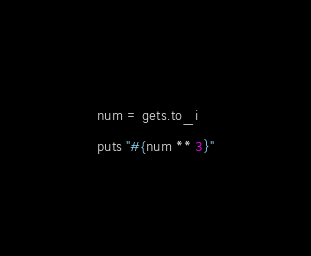Convert code to text. <code><loc_0><loc_0><loc_500><loc_500><_Ruby_>num = gets.to_i
puts "#{num ** 3}"</code> 